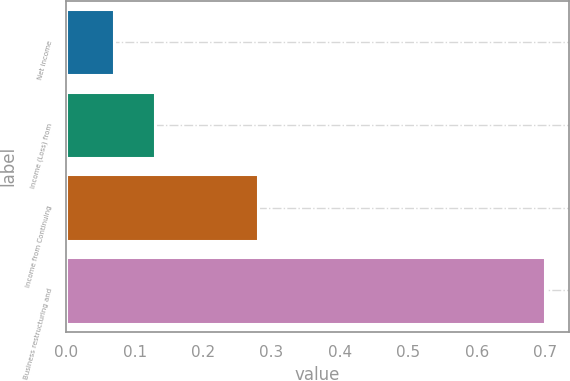<chart> <loc_0><loc_0><loc_500><loc_500><bar_chart><fcel>Net income<fcel>Income (Loss) from<fcel>Income from Continuing<fcel>Business restructuring and<nl><fcel>0.07<fcel>0.13<fcel>0.28<fcel>0.7<nl></chart> 